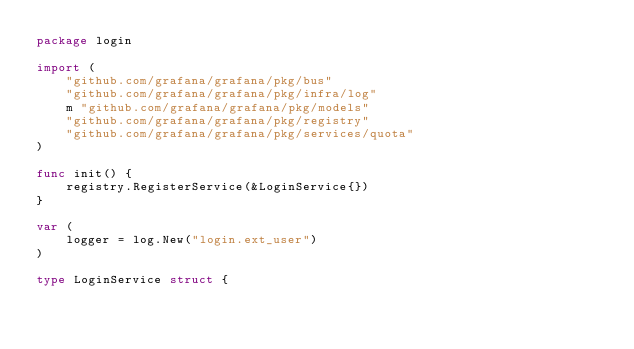<code> <loc_0><loc_0><loc_500><loc_500><_Go_>package login

import (
	"github.com/grafana/grafana/pkg/bus"
	"github.com/grafana/grafana/pkg/infra/log"
	m "github.com/grafana/grafana/pkg/models"
	"github.com/grafana/grafana/pkg/registry"
	"github.com/grafana/grafana/pkg/services/quota"
)

func init() {
	registry.RegisterService(&LoginService{})
}

var (
	logger = log.New("login.ext_user")
)

type LoginService struct {</code> 